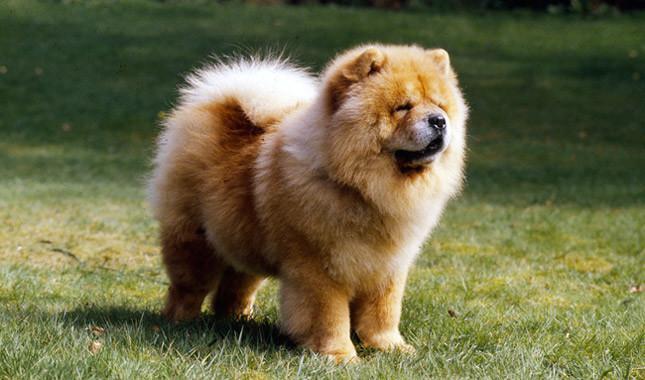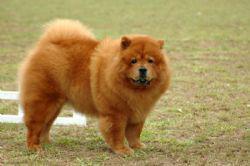The first image is the image on the left, the second image is the image on the right. For the images displayed, is the sentence "There are at least four dogs." factually correct? Answer yes or no. No. 